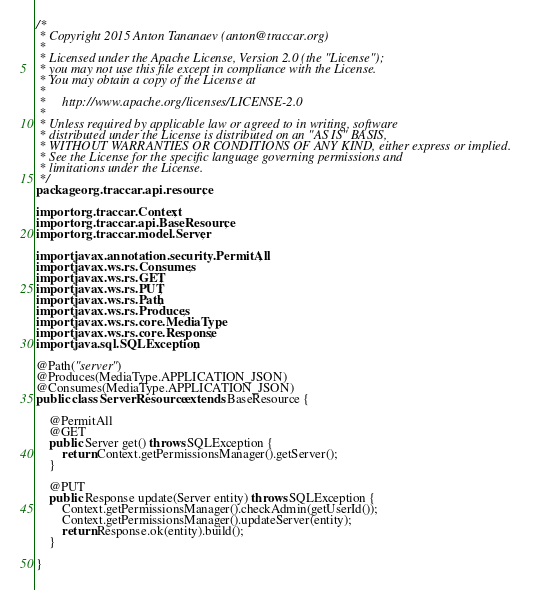Convert code to text. <code><loc_0><loc_0><loc_500><loc_500><_Java_>/*
 * Copyright 2015 Anton Tananaev (anton@traccar.org)
 *
 * Licensed under the Apache License, Version 2.0 (the "License");
 * you may not use this file except in compliance with the License.
 * You may obtain a copy of the License at
 *
 *     http://www.apache.org/licenses/LICENSE-2.0
 *
 * Unless required by applicable law or agreed to in writing, software
 * distributed under the License is distributed on an "AS IS" BASIS,
 * WITHOUT WARRANTIES OR CONDITIONS OF ANY KIND, either express or implied.
 * See the License for the specific language governing permissions and
 * limitations under the License.
 */
package org.traccar.api.resource;

import org.traccar.Context;
import org.traccar.api.BaseResource;
import org.traccar.model.Server;

import javax.annotation.security.PermitAll;
import javax.ws.rs.Consumes;
import javax.ws.rs.GET;
import javax.ws.rs.PUT;
import javax.ws.rs.Path;
import javax.ws.rs.Produces;
import javax.ws.rs.core.MediaType;
import javax.ws.rs.core.Response;
import java.sql.SQLException;

@Path("server")
@Produces(MediaType.APPLICATION_JSON)
@Consumes(MediaType.APPLICATION_JSON)
public class ServerResource extends BaseResource {

    @PermitAll
    @GET
    public Server get() throws SQLException {
        return Context.getPermissionsManager().getServer();
    }

    @PUT
    public Response update(Server entity) throws SQLException {
        Context.getPermissionsManager().checkAdmin(getUserId());
        Context.getPermissionsManager().updateServer(entity);
        return Response.ok(entity).build();
    }

}
</code> 